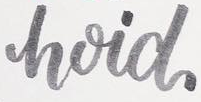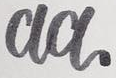What words are shown in these images in order, separated by a semicolon? hoid; aa 